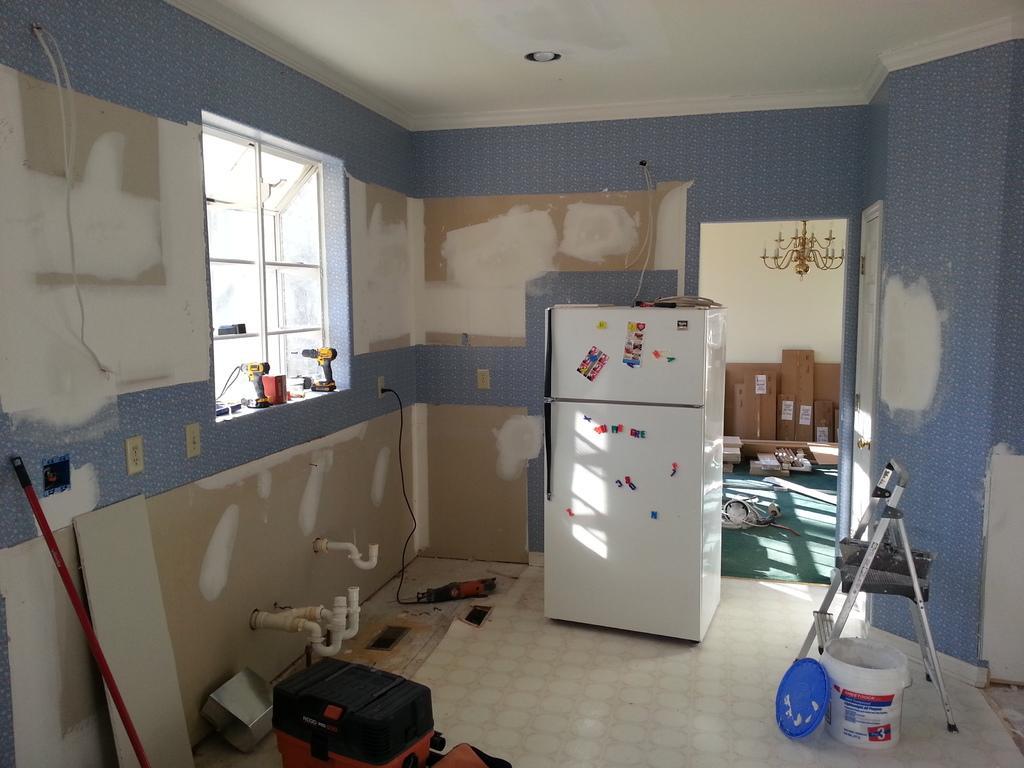How would you summarize this image in a sentence or two? This is an inside view of a room. Here I can see a refrigerator, bucket, a metal stand, boxes and some other objects are placed on the floor. On the left side there is a window to the wall and I can see few electronic devices on the window. The wall is painted with blue color. 